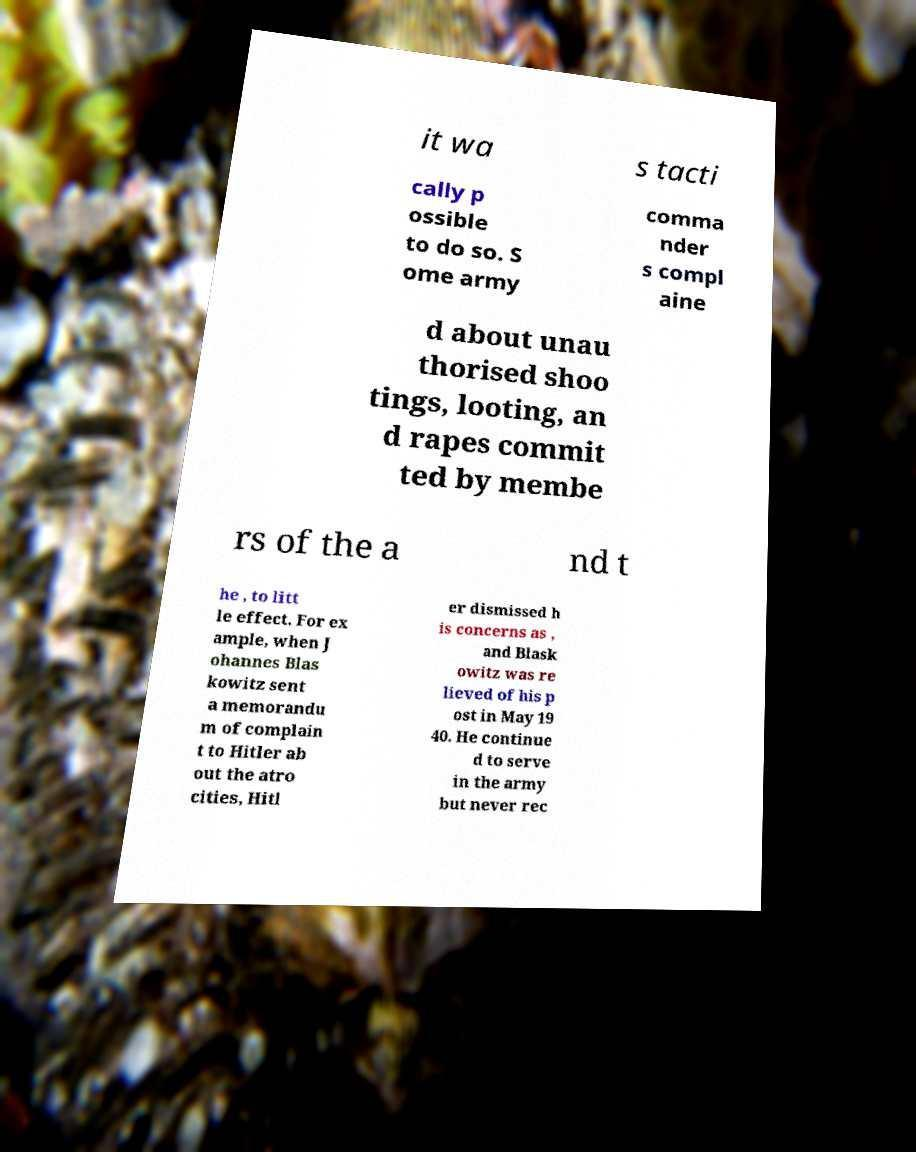Can you accurately transcribe the text from the provided image for me? it wa s tacti cally p ossible to do so. S ome army comma nder s compl aine d about unau thorised shoo tings, looting, an d rapes commit ted by membe rs of the a nd t he , to litt le effect. For ex ample, when J ohannes Blas kowitz sent a memorandu m of complain t to Hitler ab out the atro cities, Hitl er dismissed h is concerns as , and Blask owitz was re lieved of his p ost in May 19 40. He continue d to serve in the army but never rec 